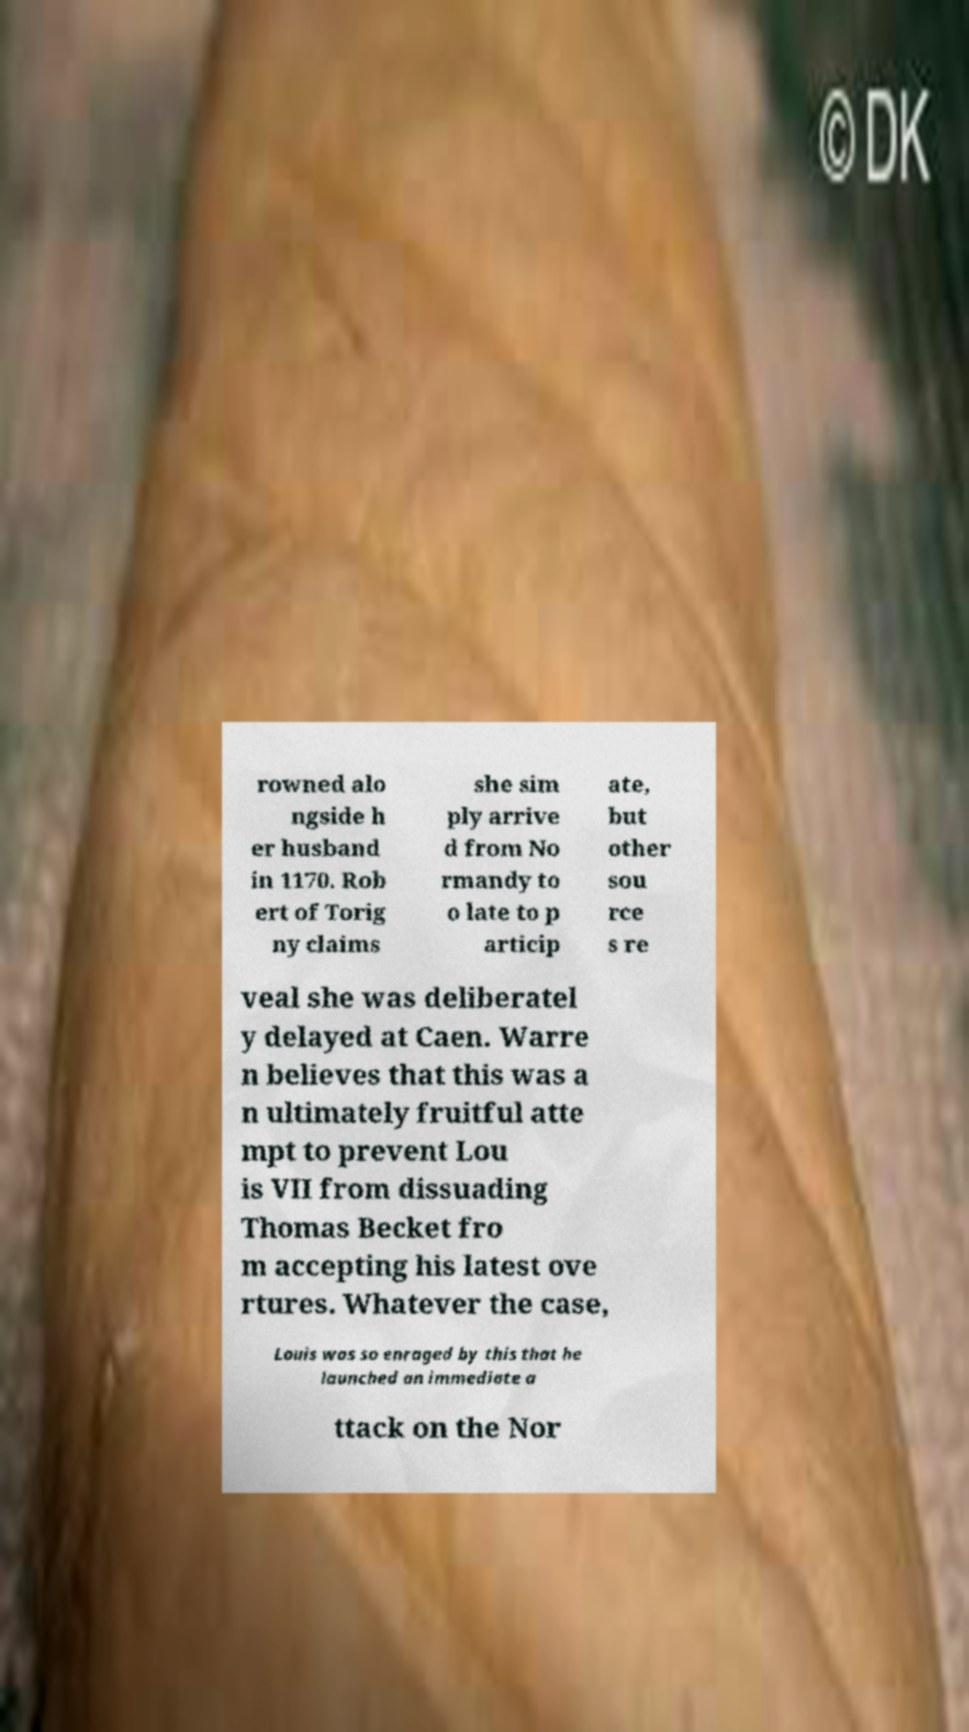What messages or text are displayed in this image? I need them in a readable, typed format. rowned alo ngside h er husband in 1170. Rob ert of Torig ny claims she sim ply arrive d from No rmandy to o late to p articip ate, but other sou rce s re veal she was deliberatel y delayed at Caen. Warre n believes that this was a n ultimately fruitful atte mpt to prevent Lou is VII from dissuading Thomas Becket fro m accepting his latest ove rtures. Whatever the case, Louis was so enraged by this that he launched an immediate a ttack on the Nor 